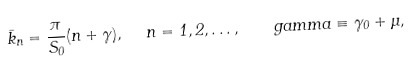Convert formula to latex. <formula><loc_0><loc_0><loc_500><loc_500>\bar { k } _ { n } = \frac { \pi } { S _ { 0 } } ( n + \gamma ) , \ \ n = 1 , 2 , \dots , \quad g a m m a \equiv \gamma _ { 0 } + \mu ,</formula> 